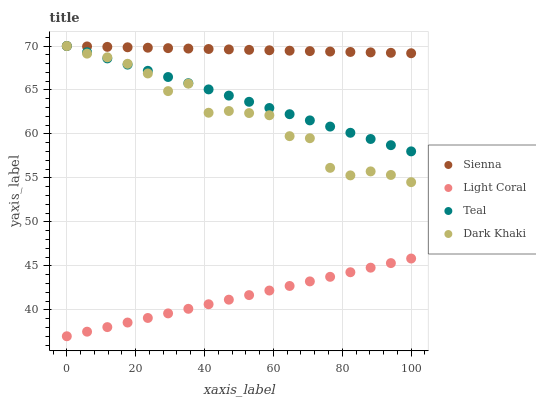Does Light Coral have the minimum area under the curve?
Answer yes or no. Yes. Does Sienna have the maximum area under the curve?
Answer yes or no. Yes. Does Dark Khaki have the minimum area under the curve?
Answer yes or no. No. Does Dark Khaki have the maximum area under the curve?
Answer yes or no. No. Is Teal the smoothest?
Answer yes or no. Yes. Is Dark Khaki the roughest?
Answer yes or no. Yes. Is Light Coral the smoothest?
Answer yes or no. No. Is Light Coral the roughest?
Answer yes or no. No. Does Light Coral have the lowest value?
Answer yes or no. Yes. Does Dark Khaki have the lowest value?
Answer yes or no. No. Does Teal have the highest value?
Answer yes or no. Yes. Does Light Coral have the highest value?
Answer yes or no. No. Is Light Coral less than Dark Khaki?
Answer yes or no. Yes. Is Teal greater than Light Coral?
Answer yes or no. Yes. Does Sienna intersect Dark Khaki?
Answer yes or no. Yes. Is Sienna less than Dark Khaki?
Answer yes or no. No. Is Sienna greater than Dark Khaki?
Answer yes or no. No. Does Light Coral intersect Dark Khaki?
Answer yes or no. No. 